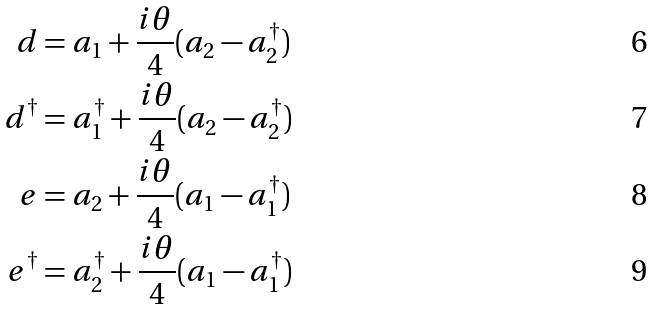Convert formula to latex. <formula><loc_0><loc_0><loc_500><loc_500>d & = a _ { 1 } + \frac { i \theta } { 4 } ( a _ { 2 } - a _ { 2 } ^ { \dagger } ) \\ d ^ { \dagger } & = a ^ { \dagger } _ { 1 } + \frac { i \theta } { 4 } ( a _ { 2 } - a _ { 2 } ^ { \dagger } ) \\ e & = a _ { 2 } + \frac { i \theta } { 4 } ( a _ { 1 } - a _ { 1 } ^ { \dagger } ) \\ e ^ { \dagger } & = a _ { 2 } ^ { \dagger } + \frac { i \theta } { 4 } ( a _ { 1 } - a _ { 1 } ^ { \dagger } )</formula> 